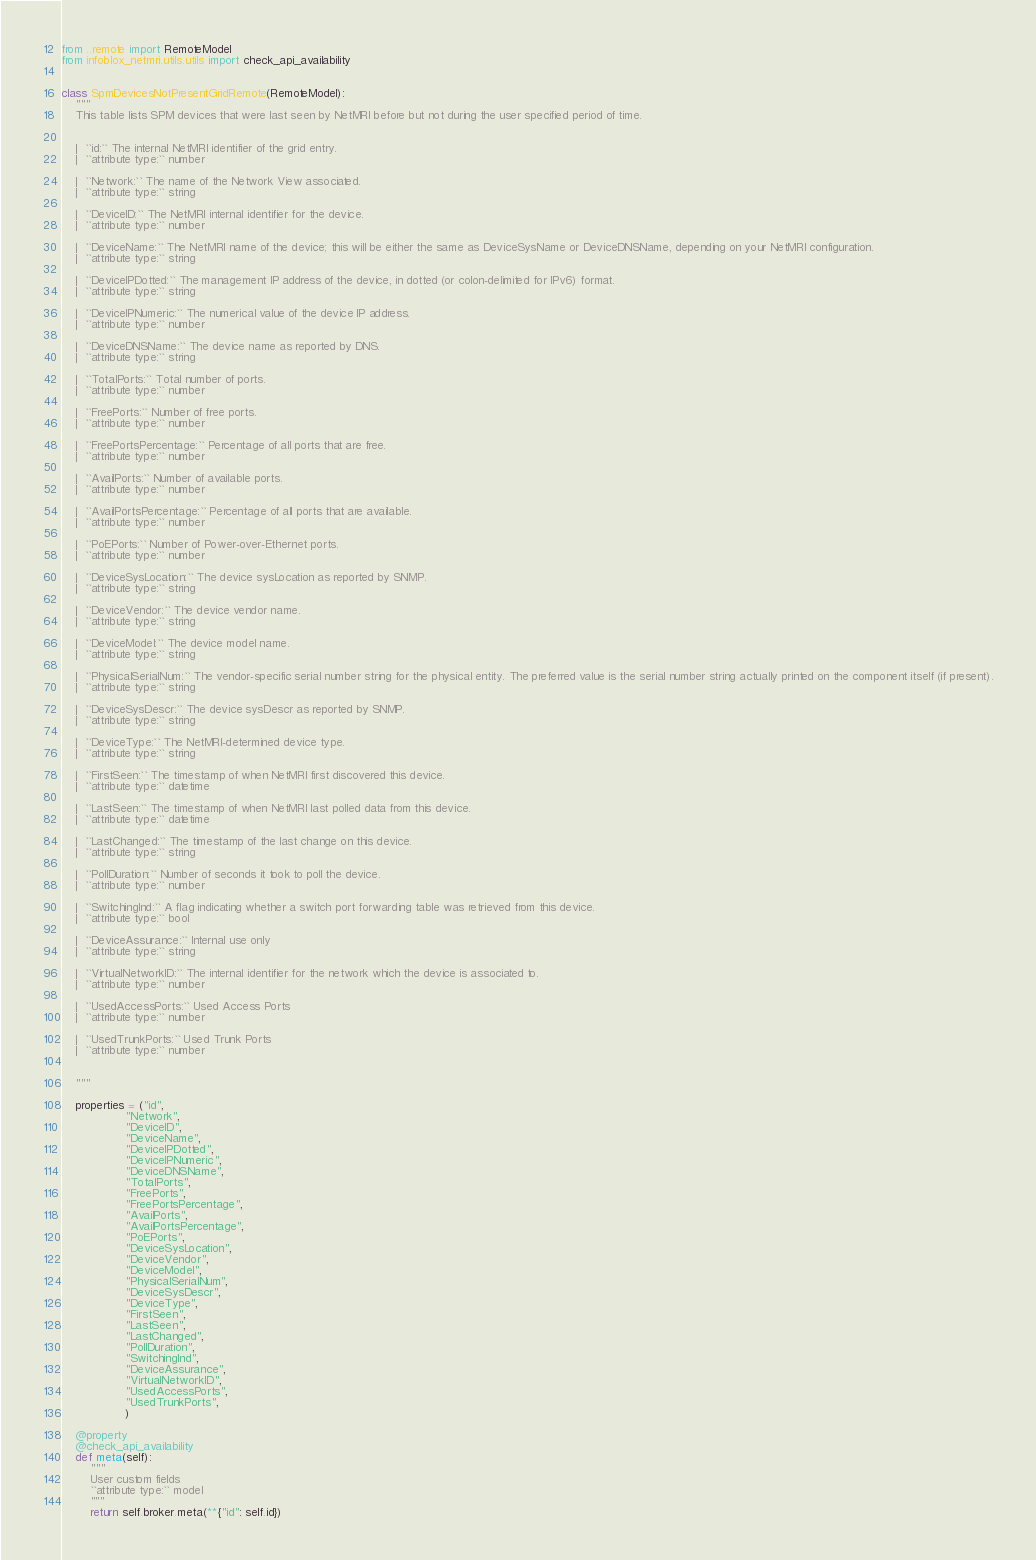<code> <loc_0><loc_0><loc_500><loc_500><_Python_>from ..remote import RemoteModel
from infoblox_netmri.utils.utils import check_api_availability


class SpmDevicesNotPresentGridRemote(RemoteModel):
    """
    This table lists SPM devices that were last seen by NetMRI before but not during the user specified period of time.


    |  ``id:`` The internal NetMRI identifier of the grid entry.
    |  ``attribute type:`` number

    |  ``Network:`` The name of the Network View associated.
    |  ``attribute type:`` string

    |  ``DeviceID:`` The NetMRI internal identifier for the device.
    |  ``attribute type:`` number

    |  ``DeviceName:`` The NetMRI name of the device; this will be either the same as DeviceSysName or DeviceDNSName, depending on your NetMRI configuration.
    |  ``attribute type:`` string

    |  ``DeviceIPDotted:`` The management IP address of the device, in dotted (or colon-delimited for IPv6) format.
    |  ``attribute type:`` string

    |  ``DeviceIPNumeric:`` The numerical value of the device IP address.
    |  ``attribute type:`` number

    |  ``DeviceDNSName:`` The device name as reported by DNS.
    |  ``attribute type:`` string

    |  ``TotalPorts:`` Total number of ports.
    |  ``attribute type:`` number

    |  ``FreePorts:`` Number of free ports.
    |  ``attribute type:`` number

    |  ``FreePortsPercentage:`` Percentage of all ports that are free.
    |  ``attribute type:`` number

    |  ``AvailPorts:`` Number of available ports.
    |  ``attribute type:`` number

    |  ``AvailPortsPercentage:`` Percentage of all ports that are available.
    |  ``attribute type:`` number

    |  ``PoEPorts:`` Number of Power-over-Ethernet ports.
    |  ``attribute type:`` number

    |  ``DeviceSysLocation:`` The device sysLocation as reported by SNMP.
    |  ``attribute type:`` string

    |  ``DeviceVendor:`` The device vendor name.
    |  ``attribute type:`` string

    |  ``DeviceModel:`` The device model name.
    |  ``attribute type:`` string

    |  ``PhysicalSerialNum:`` The vendor-specific serial number string for the physical entity. The preferred value is the serial number string actually printed on the component itself (if present).
    |  ``attribute type:`` string

    |  ``DeviceSysDescr:`` The device sysDescr as reported by SNMP.
    |  ``attribute type:`` string

    |  ``DeviceType:`` The NetMRI-determined device type.
    |  ``attribute type:`` string

    |  ``FirstSeen:`` The timestamp of when NetMRI first discovered this device.
    |  ``attribute type:`` datetime

    |  ``LastSeen:`` The timestamp of when NetMRI last polled data from this device.
    |  ``attribute type:`` datetime

    |  ``LastChanged:`` The timestamp of the last change on this device.
    |  ``attribute type:`` string

    |  ``PollDuration:`` Number of seconds it took to poll the device.
    |  ``attribute type:`` number

    |  ``SwitchingInd:`` A flag indicating whether a switch port forwarding table was retrieved from this device.
    |  ``attribute type:`` bool

    |  ``DeviceAssurance:`` Internal use only
    |  ``attribute type:`` string

    |  ``VirtualNetworkID:`` The internal identifier for the network which the device is associated to.
    |  ``attribute type:`` number

    |  ``UsedAccessPorts:`` Used Access Ports
    |  ``attribute type:`` number

    |  ``UsedTrunkPorts:`` Used Trunk Ports
    |  ``attribute type:`` number


    """

    properties = ("id",
                  "Network",
                  "DeviceID",
                  "DeviceName",
                  "DeviceIPDotted",
                  "DeviceIPNumeric",
                  "DeviceDNSName",
                  "TotalPorts",
                  "FreePorts",
                  "FreePortsPercentage",
                  "AvailPorts",
                  "AvailPortsPercentage",
                  "PoEPorts",
                  "DeviceSysLocation",
                  "DeviceVendor",
                  "DeviceModel",
                  "PhysicalSerialNum",
                  "DeviceSysDescr",
                  "DeviceType",
                  "FirstSeen",
                  "LastSeen",
                  "LastChanged",
                  "PollDuration",
                  "SwitchingInd",
                  "DeviceAssurance",
                  "VirtualNetworkID",
                  "UsedAccessPorts",
                  "UsedTrunkPorts",
                  )

    @property
    @check_api_availability
    def meta(self):
        """
        User custom fields
        ``attribute type:`` model
        """
        return self.broker.meta(**{"id": self.id})
</code> 